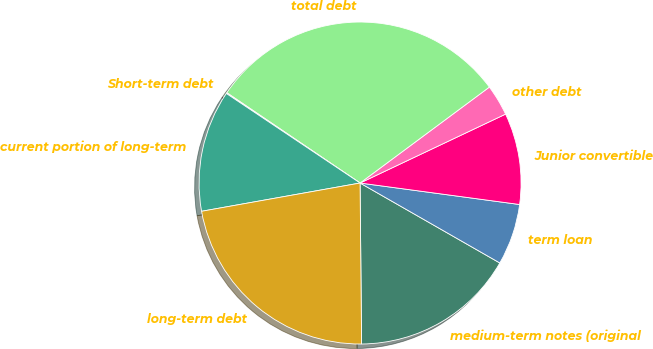Convert chart to OTSL. <chart><loc_0><loc_0><loc_500><loc_500><pie_chart><fcel>medium-term notes (original<fcel>term loan<fcel>Junior convertible<fcel>other debt<fcel>total debt<fcel>Short-term debt<fcel>current portion of long-term<fcel>long-term debt<nl><fcel>16.58%<fcel>6.14%<fcel>9.17%<fcel>3.12%<fcel>30.36%<fcel>0.09%<fcel>12.2%<fcel>22.34%<nl></chart> 